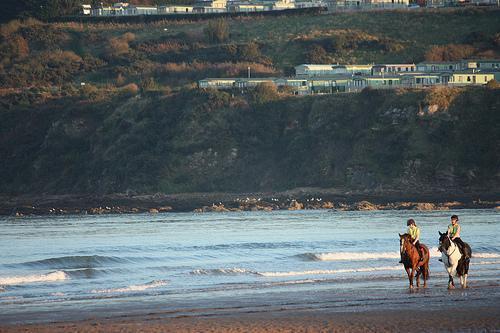How many people?
Give a very brief answer. 2. How many horses?
Give a very brief answer. 2. 